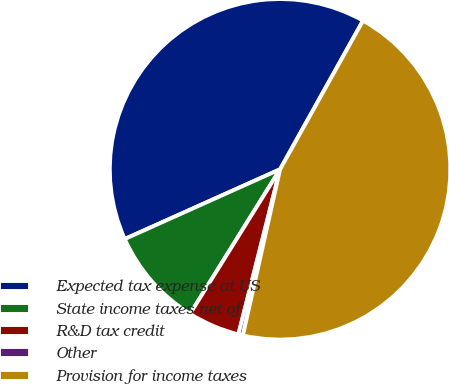<chart> <loc_0><loc_0><loc_500><loc_500><pie_chart><fcel>Expected tax expense at US<fcel>State income taxes net of<fcel>R&D tax credit<fcel>Other<fcel>Provision for income taxes<nl><fcel>39.82%<fcel>9.42%<fcel>4.93%<fcel>0.43%<fcel>45.41%<nl></chart> 